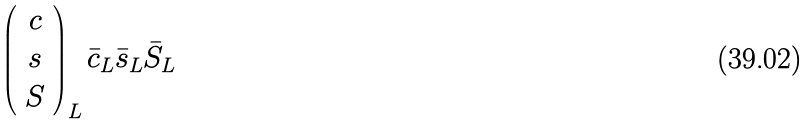<formula> <loc_0><loc_0><loc_500><loc_500>\left ( \begin{array} { c } c \\ s \\ S \end{array} \right ) _ { L } \bar { c } _ { L } \bar { s } _ { L } \bar { S } _ { L }</formula> 